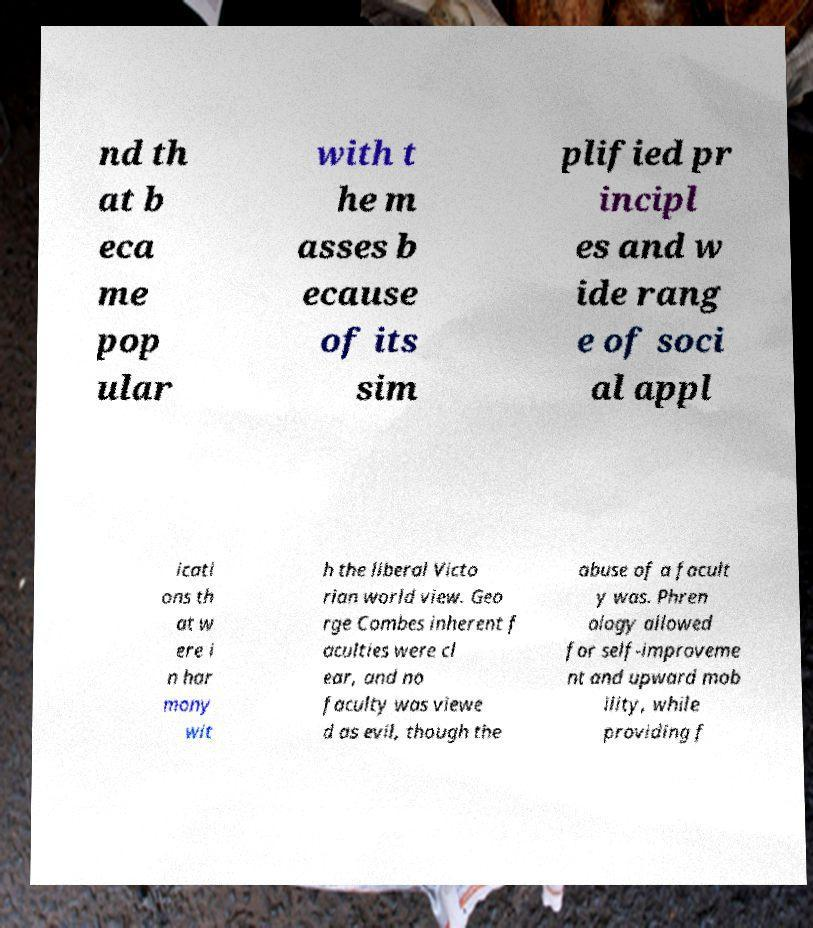Can you accurately transcribe the text from the provided image for me? nd th at b eca me pop ular with t he m asses b ecause of its sim plified pr incipl es and w ide rang e of soci al appl icati ons th at w ere i n har mony wit h the liberal Victo rian world view. Geo rge Combes inherent f aculties were cl ear, and no faculty was viewe d as evil, though the abuse of a facult y was. Phren ology allowed for self-improveme nt and upward mob ility, while providing f 